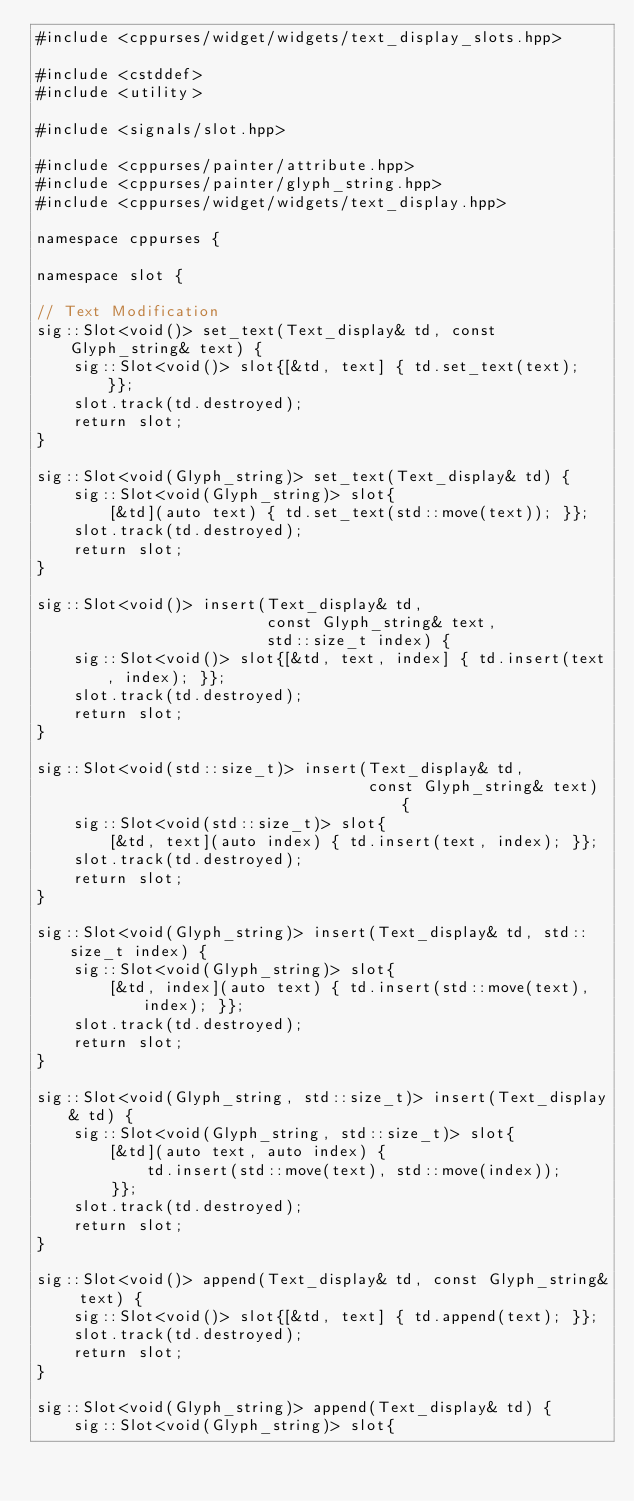<code> <loc_0><loc_0><loc_500><loc_500><_C++_>#include <cppurses/widget/widgets/text_display_slots.hpp>

#include <cstddef>
#include <utility>

#include <signals/slot.hpp>

#include <cppurses/painter/attribute.hpp>
#include <cppurses/painter/glyph_string.hpp>
#include <cppurses/widget/widgets/text_display.hpp>

namespace cppurses {

namespace slot {

// Text Modification
sig::Slot<void()> set_text(Text_display& td, const Glyph_string& text) {
    sig::Slot<void()> slot{[&td, text] { td.set_text(text); }};
    slot.track(td.destroyed);
    return slot;
}

sig::Slot<void(Glyph_string)> set_text(Text_display& td) {
    sig::Slot<void(Glyph_string)> slot{
        [&td](auto text) { td.set_text(std::move(text)); }};
    slot.track(td.destroyed);
    return slot;
}

sig::Slot<void()> insert(Text_display& td,
                         const Glyph_string& text,
                         std::size_t index) {
    sig::Slot<void()> slot{[&td, text, index] { td.insert(text, index); }};
    slot.track(td.destroyed);
    return slot;
}

sig::Slot<void(std::size_t)> insert(Text_display& td,
                                    const Glyph_string& text) {
    sig::Slot<void(std::size_t)> slot{
        [&td, text](auto index) { td.insert(text, index); }};
    slot.track(td.destroyed);
    return slot;
}

sig::Slot<void(Glyph_string)> insert(Text_display& td, std::size_t index) {
    sig::Slot<void(Glyph_string)> slot{
        [&td, index](auto text) { td.insert(std::move(text), index); }};
    slot.track(td.destroyed);
    return slot;
}

sig::Slot<void(Glyph_string, std::size_t)> insert(Text_display& td) {
    sig::Slot<void(Glyph_string, std::size_t)> slot{
        [&td](auto text, auto index) {
            td.insert(std::move(text), std::move(index));
        }};
    slot.track(td.destroyed);
    return slot;
}

sig::Slot<void()> append(Text_display& td, const Glyph_string& text) {
    sig::Slot<void()> slot{[&td, text] { td.append(text); }};
    slot.track(td.destroyed);
    return slot;
}

sig::Slot<void(Glyph_string)> append(Text_display& td) {
    sig::Slot<void(Glyph_string)> slot{</code> 